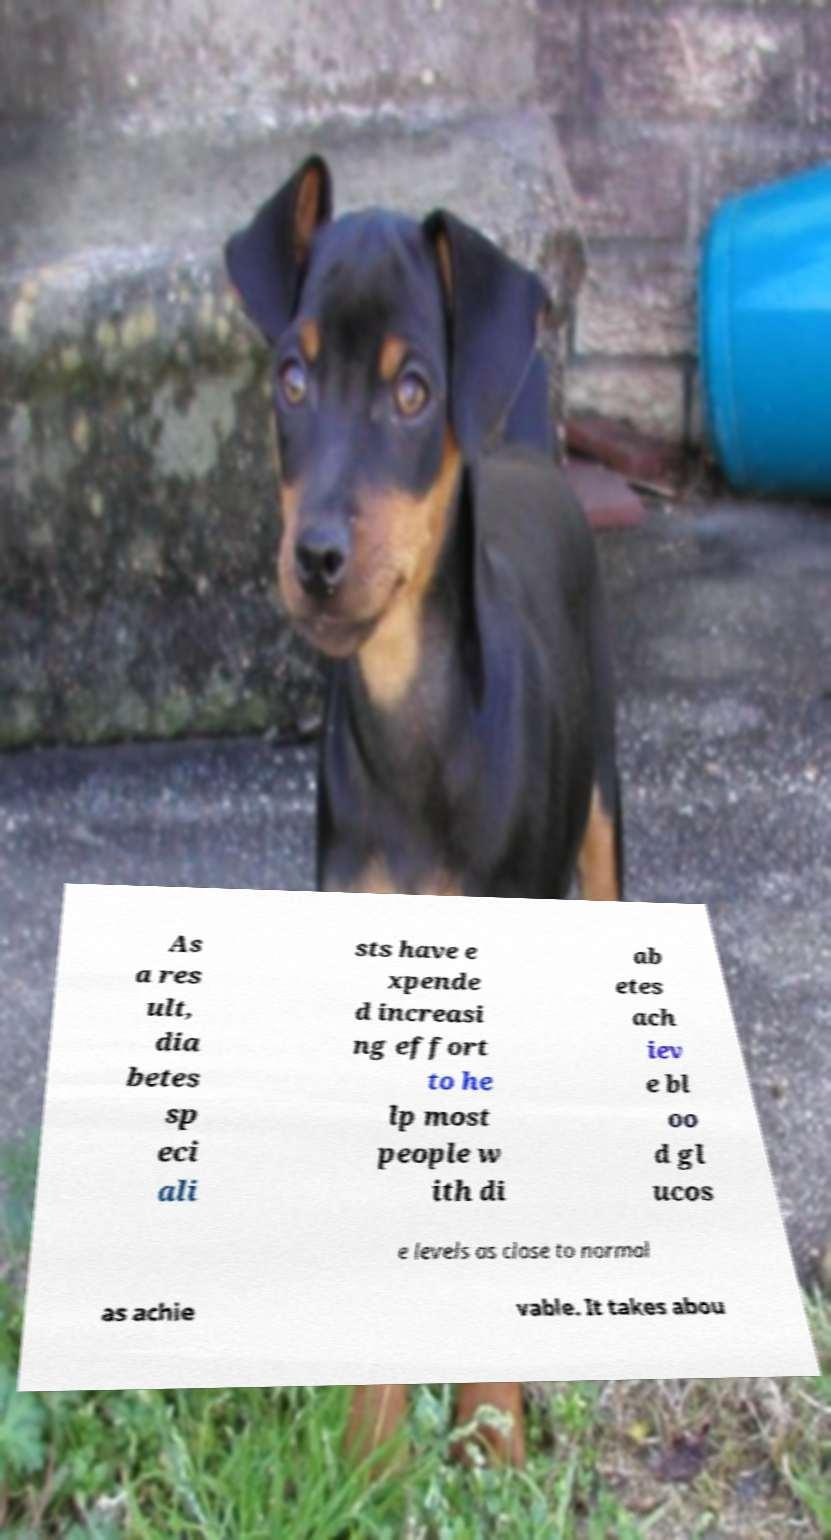What messages or text are displayed in this image? I need them in a readable, typed format. As a res ult, dia betes sp eci ali sts have e xpende d increasi ng effort to he lp most people w ith di ab etes ach iev e bl oo d gl ucos e levels as close to normal as achie vable. It takes abou 